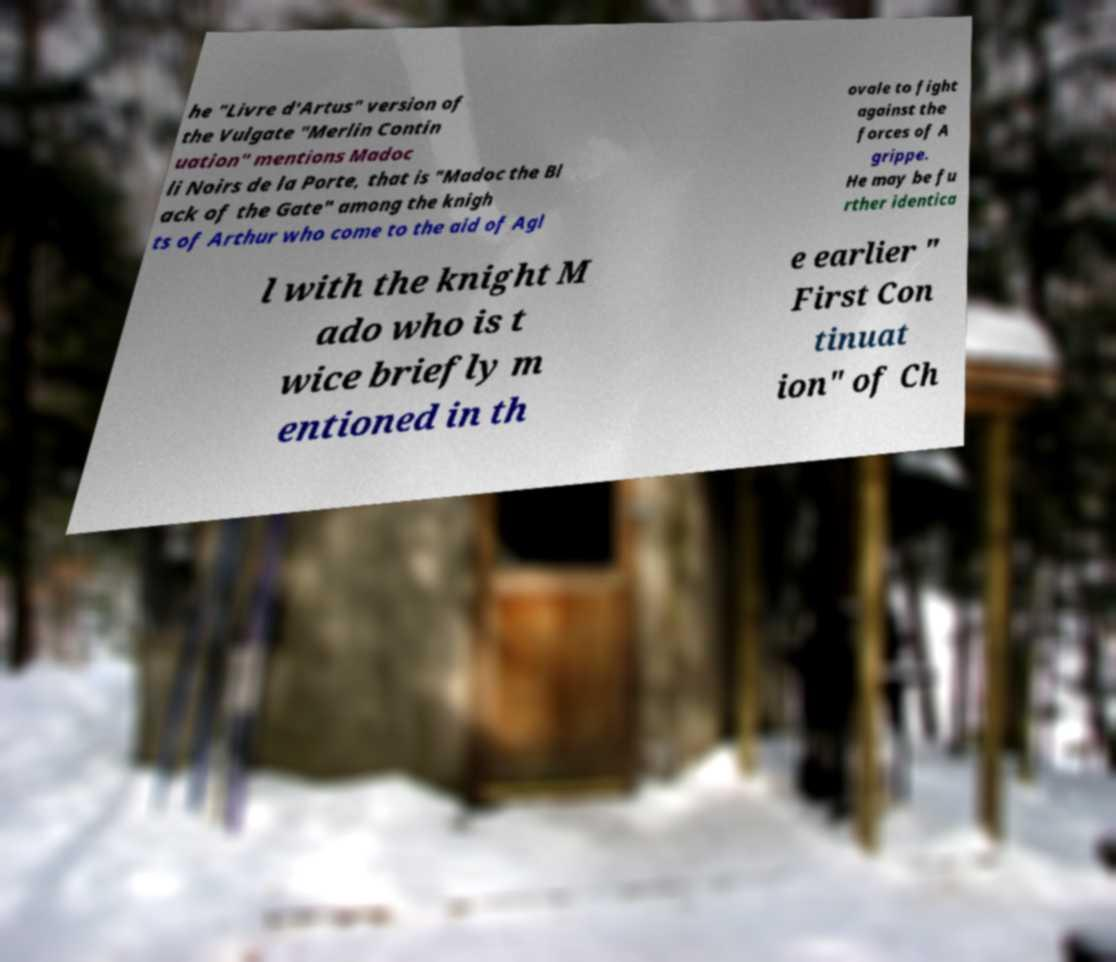Could you assist in decoding the text presented in this image and type it out clearly? he "Livre d'Artus" version of the Vulgate "Merlin Contin uation" mentions Madoc li Noirs de la Porte, that is "Madoc the Bl ack of the Gate" among the knigh ts of Arthur who come to the aid of Agl ovale to fight against the forces of A grippe. He may be fu rther identica l with the knight M ado who is t wice briefly m entioned in th e earlier " First Con tinuat ion" of Ch 